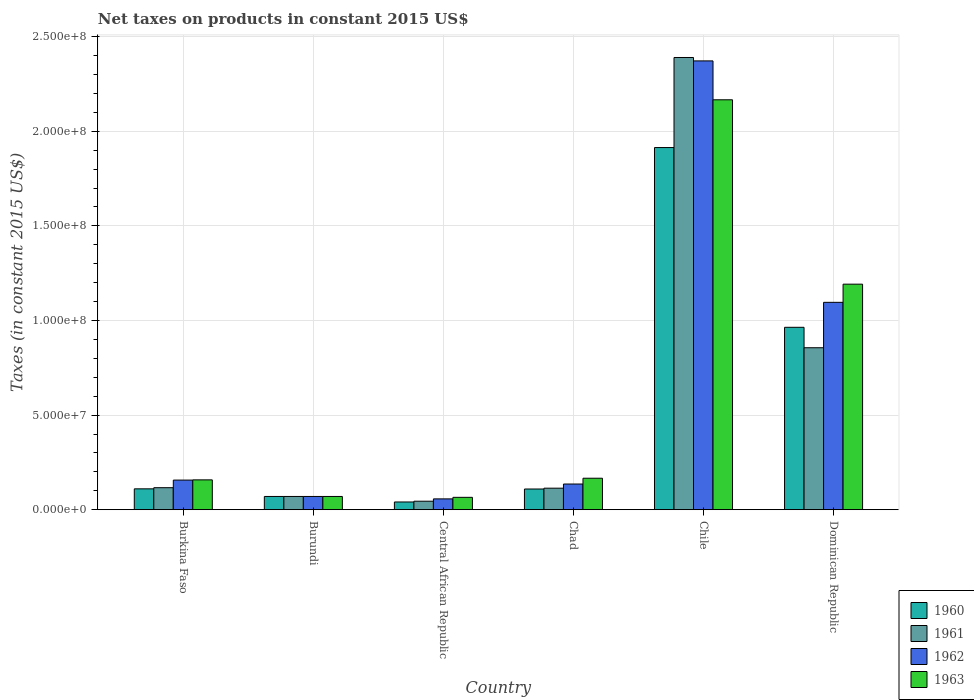Are the number of bars on each tick of the X-axis equal?
Give a very brief answer. Yes. What is the label of the 6th group of bars from the left?
Keep it short and to the point. Dominican Republic. What is the net taxes on products in 1961 in Dominican Republic?
Keep it short and to the point. 8.56e+07. Across all countries, what is the maximum net taxes on products in 1962?
Your response must be concise. 2.37e+08. Across all countries, what is the minimum net taxes on products in 1962?
Ensure brevity in your answer.  5.71e+06. In which country was the net taxes on products in 1963 minimum?
Provide a succinct answer. Central African Republic. What is the total net taxes on products in 1963 in the graph?
Your answer should be compact. 3.82e+08. What is the difference between the net taxes on products in 1963 in Burundi and that in Chad?
Keep it short and to the point. -9.63e+06. What is the difference between the net taxes on products in 1960 in Dominican Republic and the net taxes on products in 1961 in Central African Republic?
Your answer should be compact. 9.19e+07. What is the average net taxes on products in 1962 per country?
Give a very brief answer. 6.48e+07. What is the difference between the net taxes on products of/in 1961 and net taxes on products of/in 1963 in Chad?
Your answer should be very brief. -5.26e+06. In how many countries, is the net taxes on products in 1963 greater than 150000000 US$?
Give a very brief answer. 1. What is the ratio of the net taxes on products in 1961 in Chad to that in Dominican Republic?
Your answer should be very brief. 0.13. Is the net taxes on products in 1963 in Burundi less than that in Dominican Republic?
Make the answer very short. Yes. What is the difference between the highest and the second highest net taxes on products in 1962?
Your response must be concise. 9.40e+07. What is the difference between the highest and the lowest net taxes on products in 1963?
Your answer should be compact. 2.10e+08. Is it the case that in every country, the sum of the net taxes on products in 1961 and net taxes on products in 1960 is greater than the sum of net taxes on products in 1962 and net taxes on products in 1963?
Ensure brevity in your answer.  No. What does the 3rd bar from the right in Burundi represents?
Offer a very short reply. 1961. Are all the bars in the graph horizontal?
Offer a very short reply. No. What is the difference between two consecutive major ticks on the Y-axis?
Make the answer very short. 5.00e+07. Does the graph contain any zero values?
Make the answer very short. No. Does the graph contain grids?
Offer a terse response. Yes. Where does the legend appear in the graph?
Offer a very short reply. Bottom right. How many legend labels are there?
Offer a very short reply. 4. What is the title of the graph?
Your response must be concise. Net taxes on products in constant 2015 US$. Does "2006" appear as one of the legend labels in the graph?
Your answer should be very brief. No. What is the label or title of the Y-axis?
Keep it short and to the point. Taxes (in constant 2015 US$). What is the Taxes (in constant 2015 US$) of 1960 in Burkina Faso?
Provide a short and direct response. 1.10e+07. What is the Taxes (in constant 2015 US$) of 1961 in Burkina Faso?
Give a very brief answer. 1.16e+07. What is the Taxes (in constant 2015 US$) in 1962 in Burkina Faso?
Your answer should be compact. 1.56e+07. What is the Taxes (in constant 2015 US$) in 1963 in Burkina Faso?
Ensure brevity in your answer.  1.58e+07. What is the Taxes (in constant 2015 US$) of 1960 in Central African Republic?
Provide a short and direct response. 4.08e+06. What is the Taxes (in constant 2015 US$) in 1961 in Central African Republic?
Give a very brief answer. 4.49e+06. What is the Taxes (in constant 2015 US$) of 1962 in Central African Republic?
Keep it short and to the point. 5.71e+06. What is the Taxes (in constant 2015 US$) in 1963 in Central African Republic?
Provide a short and direct response. 6.53e+06. What is the Taxes (in constant 2015 US$) of 1960 in Chad?
Make the answer very short. 1.09e+07. What is the Taxes (in constant 2015 US$) of 1961 in Chad?
Provide a succinct answer. 1.14e+07. What is the Taxes (in constant 2015 US$) in 1962 in Chad?
Make the answer very short. 1.36e+07. What is the Taxes (in constant 2015 US$) of 1963 in Chad?
Your response must be concise. 1.66e+07. What is the Taxes (in constant 2015 US$) in 1960 in Chile?
Keep it short and to the point. 1.91e+08. What is the Taxes (in constant 2015 US$) in 1961 in Chile?
Ensure brevity in your answer.  2.39e+08. What is the Taxes (in constant 2015 US$) of 1962 in Chile?
Keep it short and to the point. 2.37e+08. What is the Taxes (in constant 2015 US$) of 1963 in Chile?
Provide a short and direct response. 2.17e+08. What is the Taxes (in constant 2015 US$) of 1960 in Dominican Republic?
Give a very brief answer. 9.64e+07. What is the Taxes (in constant 2015 US$) of 1961 in Dominican Republic?
Offer a very short reply. 8.56e+07. What is the Taxes (in constant 2015 US$) of 1962 in Dominican Republic?
Provide a short and direct response. 1.10e+08. What is the Taxes (in constant 2015 US$) of 1963 in Dominican Republic?
Keep it short and to the point. 1.19e+08. Across all countries, what is the maximum Taxes (in constant 2015 US$) in 1960?
Keep it short and to the point. 1.91e+08. Across all countries, what is the maximum Taxes (in constant 2015 US$) in 1961?
Your answer should be very brief. 2.39e+08. Across all countries, what is the maximum Taxes (in constant 2015 US$) of 1962?
Offer a very short reply. 2.37e+08. Across all countries, what is the maximum Taxes (in constant 2015 US$) in 1963?
Provide a short and direct response. 2.17e+08. Across all countries, what is the minimum Taxes (in constant 2015 US$) in 1960?
Offer a very short reply. 4.08e+06. Across all countries, what is the minimum Taxes (in constant 2015 US$) in 1961?
Make the answer very short. 4.49e+06. Across all countries, what is the minimum Taxes (in constant 2015 US$) of 1962?
Make the answer very short. 5.71e+06. Across all countries, what is the minimum Taxes (in constant 2015 US$) of 1963?
Give a very brief answer. 6.53e+06. What is the total Taxes (in constant 2015 US$) of 1960 in the graph?
Make the answer very short. 3.21e+08. What is the total Taxes (in constant 2015 US$) in 1961 in the graph?
Provide a succinct answer. 3.59e+08. What is the total Taxes (in constant 2015 US$) of 1962 in the graph?
Your answer should be very brief. 3.89e+08. What is the total Taxes (in constant 2015 US$) in 1963 in the graph?
Your answer should be very brief. 3.82e+08. What is the difference between the Taxes (in constant 2015 US$) in 1960 in Burkina Faso and that in Burundi?
Provide a succinct answer. 4.02e+06. What is the difference between the Taxes (in constant 2015 US$) in 1961 in Burkina Faso and that in Burundi?
Give a very brief answer. 4.63e+06. What is the difference between the Taxes (in constant 2015 US$) in 1962 in Burkina Faso and that in Burundi?
Your answer should be very brief. 8.65e+06. What is the difference between the Taxes (in constant 2015 US$) of 1963 in Burkina Faso and that in Burundi?
Your answer should be very brief. 8.77e+06. What is the difference between the Taxes (in constant 2015 US$) of 1960 in Burkina Faso and that in Central African Republic?
Your answer should be compact. 6.94e+06. What is the difference between the Taxes (in constant 2015 US$) of 1961 in Burkina Faso and that in Central African Republic?
Your response must be concise. 7.15e+06. What is the difference between the Taxes (in constant 2015 US$) in 1962 in Burkina Faso and that in Central African Republic?
Offer a very short reply. 9.93e+06. What is the difference between the Taxes (in constant 2015 US$) of 1963 in Burkina Faso and that in Central African Republic?
Offer a very short reply. 9.24e+06. What is the difference between the Taxes (in constant 2015 US$) of 1960 in Burkina Faso and that in Chad?
Make the answer very short. 8.71e+04. What is the difference between the Taxes (in constant 2015 US$) in 1961 in Burkina Faso and that in Chad?
Keep it short and to the point. 2.61e+05. What is the difference between the Taxes (in constant 2015 US$) of 1962 in Burkina Faso and that in Chad?
Keep it short and to the point. 2.08e+06. What is the difference between the Taxes (in constant 2015 US$) of 1963 in Burkina Faso and that in Chad?
Give a very brief answer. -8.65e+05. What is the difference between the Taxes (in constant 2015 US$) of 1960 in Burkina Faso and that in Chile?
Offer a terse response. -1.80e+08. What is the difference between the Taxes (in constant 2015 US$) in 1961 in Burkina Faso and that in Chile?
Provide a succinct answer. -2.27e+08. What is the difference between the Taxes (in constant 2015 US$) of 1962 in Burkina Faso and that in Chile?
Offer a very short reply. -2.22e+08. What is the difference between the Taxes (in constant 2015 US$) in 1963 in Burkina Faso and that in Chile?
Your response must be concise. -2.01e+08. What is the difference between the Taxes (in constant 2015 US$) of 1960 in Burkina Faso and that in Dominican Republic?
Provide a short and direct response. -8.54e+07. What is the difference between the Taxes (in constant 2015 US$) in 1961 in Burkina Faso and that in Dominican Republic?
Provide a short and direct response. -7.40e+07. What is the difference between the Taxes (in constant 2015 US$) of 1962 in Burkina Faso and that in Dominican Republic?
Provide a succinct answer. -9.40e+07. What is the difference between the Taxes (in constant 2015 US$) in 1963 in Burkina Faso and that in Dominican Republic?
Make the answer very short. -1.03e+08. What is the difference between the Taxes (in constant 2015 US$) in 1960 in Burundi and that in Central African Republic?
Your response must be concise. 2.92e+06. What is the difference between the Taxes (in constant 2015 US$) of 1961 in Burundi and that in Central African Republic?
Provide a succinct answer. 2.51e+06. What is the difference between the Taxes (in constant 2015 US$) in 1962 in Burundi and that in Central African Republic?
Give a very brief answer. 1.29e+06. What is the difference between the Taxes (in constant 2015 US$) in 1963 in Burundi and that in Central African Republic?
Provide a succinct answer. 4.70e+05. What is the difference between the Taxes (in constant 2015 US$) of 1960 in Burundi and that in Chad?
Provide a short and direct response. -3.94e+06. What is the difference between the Taxes (in constant 2015 US$) in 1961 in Burundi and that in Chad?
Provide a short and direct response. -4.37e+06. What is the difference between the Taxes (in constant 2015 US$) of 1962 in Burundi and that in Chad?
Give a very brief answer. -6.57e+06. What is the difference between the Taxes (in constant 2015 US$) in 1963 in Burundi and that in Chad?
Provide a succinct answer. -9.63e+06. What is the difference between the Taxes (in constant 2015 US$) of 1960 in Burundi and that in Chile?
Your answer should be compact. -1.84e+08. What is the difference between the Taxes (in constant 2015 US$) of 1961 in Burundi and that in Chile?
Keep it short and to the point. -2.32e+08. What is the difference between the Taxes (in constant 2015 US$) of 1962 in Burundi and that in Chile?
Provide a short and direct response. -2.30e+08. What is the difference between the Taxes (in constant 2015 US$) in 1963 in Burundi and that in Chile?
Make the answer very short. -2.10e+08. What is the difference between the Taxes (in constant 2015 US$) of 1960 in Burundi and that in Dominican Republic?
Your response must be concise. -8.94e+07. What is the difference between the Taxes (in constant 2015 US$) in 1961 in Burundi and that in Dominican Republic?
Offer a terse response. -7.86e+07. What is the difference between the Taxes (in constant 2015 US$) in 1962 in Burundi and that in Dominican Republic?
Make the answer very short. -1.03e+08. What is the difference between the Taxes (in constant 2015 US$) of 1963 in Burundi and that in Dominican Republic?
Keep it short and to the point. -1.12e+08. What is the difference between the Taxes (in constant 2015 US$) of 1960 in Central African Republic and that in Chad?
Your response must be concise. -6.86e+06. What is the difference between the Taxes (in constant 2015 US$) of 1961 in Central African Republic and that in Chad?
Your answer should be very brief. -6.88e+06. What is the difference between the Taxes (in constant 2015 US$) of 1962 in Central African Republic and that in Chad?
Make the answer very short. -7.86e+06. What is the difference between the Taxes (in constant 2015 US$) in 1963 in Central African Republic and that in Chad?
Provide a succinct answer. -1.01e+07. What is the difference between the Taxes (in constant 2015 US$) in 1960 in Central African Republic and that in Chile?
Offer a terse response. -1.87e+08. What is the difference between the Taxes (in constant 2015 US$) in 1961 in Central African Republic and that in Chile?
Your answer should be compact. -2.35e+08. What is the difference between the Taxes (in constant 2015 US$) in 1962 in Central African Republic and that in Chile?
Ensure brevity in your answer.  -2.31e+08. What is the difference between the Taxes (in constant 2015 US$) of 1963 in Central African Republic and that in Chile?
Your answer should be compact. -2.10e+08. What is the difference between the Taxes (in constant 2015 US$) in 1960 in Central African Republic and that in Dominican Republic?
Your answer should be very brief. -9.23e+07. What is the difference between the Taxes (in constant 2015 US$) in 1961 in Central African Republic and that in Dominican Republic?
Your response must be concise. -8.11e+07. What is the difference between the Taxes (in constant 2015 US$) of 1962 in Central African Republic and that in Dominican Republic?
Provide a short and direct response. -1.04e+08. What is the difference between the Taxes (in constant 2015 US$) of 1963 in Central African Republic and that in Dominican Republic?
Give a very brief answer. -1.13e+08. What is the difference between the Taxes (in constant 2015 US$) of 1960 in Chad and that in Chile?
Provide a short and direct response. -1.80e+08. What is the difference between the Taxes (in constant 2015 US$) of 1961 in Chad and that in Chile?
Make the answer very short. -2.28e+08. What is the difference between the Taxes (in constant 2015 US$) of 1962 in Chad and that in Chile?
Ensure brevity in your answer.  -2.24e+08. What is the difference between the Taxes (in constant 2015 US$) of 1963 in Chad and that in Chile?
Make the answer very short. -2.00e+08. What is the difference between the Taxes (in constant 2015 US$) of 1960 in Chad and that in Dominican Republic?
Provide a short and direct response. -8.55e+07. What is the difference between the Taxes (in constant 2015 US$) of 1961 in Chad and that in Dominican Republic?
Your response must be concise. -7.42e+07. What is the difference between the Taxes (in constant 2015 US$) in 1962 in Chad and that in Dominican Republic?
Keep it short and to the point. -9.60e+07. What is the difference between the Taxes (in constant 2015 US$) in 1963 in Chad and that in Dominican Republic?
Your answer should be compact. -1.03e+08. What is the difference between the Taxes (in constant 2015 US$) in 1960 in Chile and that in Dominican Republic?
Your answer should be very brief. 9.50e+07. What is the difference between the Taxes (in constant 2015 US$) of 1961 in Chile and that in Dominican Republic?
Provide a short and direct response. 1.53e+08. What is the difference between the Taxes (in constant 2015 US$) of 1962 in Chile and that in Dominican Republic?
Provide a short and direct response. 1.28e+08. What is the difference between the Taxes (in constant 2015 US$) of 1963 in Chile and that in Dominican Republic?
Keep it short and to the point. 9.74e+07. What is the difference between the Taxes (in constant 2015 US$) of 1960 in Burkina Faso and the Taxes (in constant 2015 US$) of 1961 in Burundi?
Ensure brevity in your answer.  4.02e+06. What is the difference between the Taxes (in constant 2015 US$) in 1960 in Burkina Faso and the Taxes (in constant 2015 US$) in 1962 in Burundi?
Make the answer very short. 4.02e+06. What is the difference between the Taxes (in constant 2015 US$) of 1960 in Burkina Faso and the Taxes (in constant 2015 US$) of 1963 in Burundi?
Your response must be concise. 4.02e+06. What is the difference between the Taxes (in constant 2015 US$) in 1961 in Burkina Faso and the Taxes (in constant 2015 US$) in 1962 in Burundi?
Make the answer very short. 4.63e+06. What is the difference between the Taxes (in constant 2015 US$) in 1961 in Burkina Faso and the Taxes (in constant 2015 US$) in 1963 in Burundi?
Provide a short and direct response. 4.63e+06. What is the difference between the Taxes (in constant 2015 US$) in 1962 in Burkina Faso and the Taxes (in constant 2015 US$) in 1963 in Burundi?
Offer a terse response. 8.65e+06. What is the difference between the Taxes (in constant 2015 US$) of 1960 in Burkina Faso and the Taxes (in constant 2015 US$) of 1961 in Central African Republic?
Provide a succinct answer. 6.54e+06. What is the difference between the Taxes (in constant 2015 US$) of 1960 in Burkina Faso and the Taxes (in constant 2015 US$) of 1962 in Central African Republic?
Provide a succinct answer. 5.31e+06. What is the difference between the Taxes (in constant 2015 US$) in 1960 in Burkina Faso and the Taxes (in constant 2015 US$) in 1963 in Central African Republic?
Provide a short and direct response. 4.49e+06. What is the difference between the Taxes (in constant 2015 US$) of 1961 in Burkina Faso and the Taxes (in constant 2015 US$) of 1962 in Central African Republic?
Your answer should be compact. 5.92e+06. What is the difference between the Taxes (in constant 2015 US$) of 1961 in Burkina Faso and the Taxes (in constant 2015 US$) of 1963 in Central African Republic?
Ensure brevity in your answer.  5.10e+06. What is the difference between the Taxes (in constant 2015 US$) in 1962 in Burkina Faso and the Taxes (in constant 2015 US$) in 1963 in Central African Republic?
Provide a short and direct response. 9.12e+06. What is the difference between the Taxes (in constant 2015 US$) in 1960 in Burkina Faso and the Taxes (in constant 2015 US$) in 1961 in Chad?
Your answer should be compact. -3.47e+05. What is the difference between the Taxes (in constant 2015 US$) in 1960 in Burkina Faso and the Taxes (in constant 2015 US$) in 1962 in Chad?
Offer a very short reply. -2.55e+06. What is the difference between the Taxes (in constant 2015 US$) in 1960 in Burkina Faso and the Taxes (in constant 2015 US$) in 1963 in Chad?
Keep it short and to the point. -5.61e+06. What is the difference between the Taxes (in constant 2015 US$) in 1961 in Burkina Faso and the Taxes (in constant 2015 US$) in 1962 in Chad?
Ensure brevity in your answer.  -1.94e+06. What is the difference between the Taxes (in constant 2015 US$) of 1961 in Burkina Faso and the Taxes (in constant 2015 US$) of 1963 in Chad?
Ensure brevity in your answer.  -5.00e+06. What is the difference between the Taxes (in constant 2015 US$) in 1962 in Burkina Faso and the Taxes (in constant 2015 US$) in 1963 in Chad?
Provide a short and direct response. -9.87e+05. What is the difference between the Taxes (in constant 2015 US$) of 1960 in Burkina Faso and the Taxes (in constant 2015 US$) of 1961 in Chile?
Offer a very short reply. -2.28e+08. What is the difference between the Taxes (in constant 2015 US$) of 1960 in Burkina Faso and the Taxes (in constant 2015 US$) of 1962 in Chile?
Provide a succinct answer. -2.26e+08. What is the difference between the Taxes (in constant 2015 US$) in 1960 in Burkina Faso and the Taxes (in constant 2015 US$) in 1963 in Chile?
Provide a succinct answer. -2.06e+08. What is the difference between the Taxes (in constant 2015 US$) in 1961 in Burkina Faso and the Taxes (in constant 2015 US$) in 1962 in Chile?
Your answer should be very brief. -2.26e+08. What is the difference between the Taxes (in constant 2015 US$) in 1961 in Burkina Faso and the Taxes (in constant 2015 US$) in 1963 in Chile?
Your answer should be very brief. -2.05e+08. What is the difference between the Taxes (in constant 2015 US$) of 1962 in Burkina Faso and the Taxes (in constant 2015 US$) of 1963 in Chile?
Your response must be concise. -2.01e+08. What is the difference between the Taxes (in constant 2015 US$) in 1960 in Burkina Faso and the Taxes (in constant 2015 US$) in 1961 in Dominican Republic?
Make the answer very short. -7.46e+07. What is the difference between the Taxes (in constant 2015 US$) in 1960 in Burkina Faso and the Taxes (in constant 2015 US$) in 1962 in Dominican Republic?
Provide a short and direct response. -9.86e+07. What is the difference between the Taxes (in constant 2015 US$) of 1960 in Burkina Faso and the Taxes (in constant 2015 US$) of 1963 in Dominican Republic?
Ensure brevity in your answer.  -1.08e+08. What is the difference between the Taxes (in constant 2015 US$) in 1961 in Burkina Faso and the Taxes (in constant 2015 US$) in 1962 in Dominican Republic?
Offer a terse response. -9.80e+07. What is the difference between the Taxes (in constant 2015 US$) in 1961 in Burkina Faso and the Taxes (in constant 2015 US$) in 1963 in Dominican Republic?
Ensure brevity in your answer.  -1.08e+08. What is the difference between the Taxes (in constant 2015 US$) in 1962 in Burkina Faso and the Taxes (in constant 2015 US$) in 1963 in Dominican Republic?
Your answer should be compact. -1.04e+08. What is the difference between the Taxes (in constant 2015 US$) in 1960 in Burundi and the Taxes (in constant 2015 US$) in 1961 in Central African Republic?
Keep it short and to the point. 2.51e+06. What is the difference between the Taxes (in constant 2015 US$) in 1960 in Burundi and the Taxes (in constant 2015 US$) in 1962 in Central African Republic?
Give a very brief answer. 1.29e+06. What is the difference between the Taxes (in constant 2015 US$) of 1960 in Burundi and the Taxes (in constant 2015 US$) of 1963 in Central African Republic?
Your answer should be compact. 4.70e+05. What is the difference between the Taxes (in constant 2015 US$) in 1961 in Burundi and the Taxes (in constant 2015 US$) in 1962 in Central African Republic?
Provide a succinct answer. 1.29e+06. What is the difference between the Taxes (in constant 2015 US$) in 1961 in Burundi and the Taxes (in constant 2015 US$) in 1963 in Central African Republic?
Keep it short and to the point. 4.70e+05. What is the difference between the Taxes (in constant 2015 US$) in 1962 in Burundi and the Taxes (in constant 2015 US$) in 1963 in Central African Republic?
Your answer should be compact. 4.70e+05. What is the difference between the Taxes (in constant 2015 US$) in 1960 in Burundi and the Taxes (in constant 2015 US$) in 1961 in Chad?
Your response must be concise. -4.37e+06. What is the difference between the Taxes (in constant 2015 US$) in 1960 in Burundi and the Taxes (in constant 2015 US$) in 1962 in Chad?
Offer a very short reply. -6.57e+06. What is the difference between the Taxes (in constant 2015 US$) in 1960 in Burundi and the Taxes (in constant 2015 US$) in 1963 in Chad?
Your response must be concise. -9.63e+06. What is the difference between the Taxes (in constant 2015 US$) in 1961 in Burundi and the Taxes (in constant 2015 US$) in 1962 in Chad?
Give a very brief answer. -6.57e+06. What is the difference between the Taxes (in constant 2015 US$) in 1961 in Burundi and the Taxes (in constant 2015 US$) in 1963 in Chad?
Provide a succinct answer. -9.63e+06. What is the difference between the Taxes (in constant 2015 US$) of 1962 in Burundi and the Taxes (in constant 2015 US$) of 1963 in Chad?
Provide a short and direct response. -9.63e+06. What is the difference between the Taxes (in constant 2015 US$) of 1960 in Burundi and the Taxes (in constant 2015 US$) of 1961 in Chile?
Ensure brevity in your answer.  -2.32e+08. What is the difference between the Taxes (in constant 2015 US$) of 1960 in Burundi and the Taxes (in constant 2015 US$) of 1962 in Chile?
Offer a very short reply. -2.30e+08. What is the difference between the Taxes (in constant 2015 US$) of 1960 in Burundi and the Taxes (in constant 2015 US$) of 1963 in Chile?
Your response must be concise. -2.10e+08. What is the difference between the Taxes (in constant 2015 US$) of 1961 in Burundi and the Taxes (in constant 2015 US$) of 1962 in Chile?
Your answer should be compact. -2.30e+08. What is the difference between the Taxes (in constant 2015 US$) in 1961 in Burundi and the Taxes (in constant 2015 US$) in 1963 in Chile?
Provide a short and direct response. -2.10e+08. What is the difference between the Taxes (in constant 2015 US$) of 1962 in Burundi and the Taxes (in constant 2015 US$) of 1963 in Chile?
Your response must be concise. -2.10e+08. What is the difference between the Taxes (in constant 2015 US$) in 1960 in Burundi and the Taxes (in constant 2015 US$) in 1961 in Dominican Republic?
Your answer should be very brief. -7.86e+07. What is the difference between the Taxes (in constant 2015 US$) of 1960 in Burundi and the Taxes (in constant 2015 US$) of 1962 in Dominican Republic?
Your answer should be very brief. -1.03e+08. What is the difference between the Taxes (in constant 2015 US$) of 1960 in Burundi and the Taxes (in constant 2015 US$) of 1963 in Dominican Republic?
Offer a terse response. -1.12e+08. What is the difference between the Taxes (in constant 2015 US$) in 1961 in Burundi and the Taxes (in constant 2015 US$) in 1962 in Dominican Republic?
Provide a short and direct response. -1.03e+08. What is the difference between the Taxes (in constant 2015 US$) in 1961 in Burundi and the Taxes (in constant 2015 US$) in 1963 in Dominican Republic?
Keep it short and to the point. -1.12e+08. What is the difference between the Taxes (in constant 2015 US$) in 1962 in Burundi and the Taxes (in constant 2015 US$) in 1963 in Dominican Republic?
Ensure brevity in your answer.  -1.12e+08. What is the difference between the Taxes (in constant 2015 US$) of 1960 in Central African Republic and the Taxes (in constant 2015 US$) of 1961 in Chad?
Give a very brief answer. -7.29e+06. What is the difference between the Taxes (in constant 2015 US$) of 1960 in Central African Republic and the Taxes (in constant 2015 US$) of 1962 in Chad?
Provide a short and direct response. -9.49e+06. What is the difference between the Taxes (in constant 2015 US$) in 1960 in Central African Republic and the Taxes (in constant 2015 US$) in 1963 in Chad?
Your answer should be very brief. -1.26e+07. What is the difference between the Taxes (in constant 2015 US$) of 1961 in Central African Republic and the Taxes (in constant 2015 US$) of 1962 in Chad?
Offer a very short reply. -9.08e+06. What is the difference between the Taxes (in constant 2015 US$) of 1961 in Central African Republic and the Taxes (in constant 2015 US$) of 1963 in Chad?
Your answer should be compact. -1.21e+07. What is the difference between the Taxes (in constant 2015 US$) of 1962 in Central African Republic and the Taxes (in constant 2015 US$) of 1963 in Chad?
Offer a terse response. -1.09e+07. What is the difference between the Taxes (in constant 2015 US$) of 1960 in Central African Republic and the Taxes (in constant 2015 US$) of 1961 in Chile?
Your answer should be compact. -2.35e+08. What is the difference between the Taxes (in constant 2015 US$) of 1960 in Central African Republic and the Taxes (in constant 2015 US$) of 1962 in Chile?
Offer a very short reply. -2.33e+08. What is the difference between the Taxes (in constant 2015 US$) of 1960 in Central African Republic and the Taxes (in constant 2015 US$) of 1963 in Chile?
Keep it short and to the point. -2.13e+08. What is the difference between the Taxes (in constant 2015 US$) in 1961 in Central African Republic and the Taxes (in constant 2015 US$) in 1962 in Chile?
Your answer should be very brief. -2.33e+08. What is the difference between the Taxes (in constant 2015 US$) of 1961 in Central African Republic and the Taxes (in constant 2015 US$) of 1963 in Chile?
Provide a short and direct response. -2.12e+08. What is the difference between the Taxes (in constant 2015 US$) in 1962 in Central African Republic and the Taxes (in constant 2015 US$) in 1963 in Chile?
Provide a succinct answer. -2.11e+08. What is the difference between the Taxes (in constant 2015 US$) of 1960 in Central African Republic and the Taxes (in constant 2015 US$) of 1961 in Dominican Republic?
Your answer should be very brief. -8.15e+07. What is the difference between the Taxes (in constant 2015 US$) of 1960 in Central African Republic and the Taxes (in constant 2015 US$) of 1962 in Dominican Republic?
Your answer should be compact. -1.06e+08. What is the difference between the Taxes (in constant 2015 US$) in 1960 in Central African Republic and the Taxes (in constant 2015 US$) in 1963 in Dominican Republic?
Offer a very short reply. -1.15e+08. What is the difference between the Taxes (in constant 2015 US$) in 1961 in Central African Republic and the Taxes (in constant 2015 US$) in 1962 in Dominican Republic?
Keep it short and to the point. -1.05e+08. What is the difference between the Taxes (in constant 2015 US$) in 1961 in Central African Republic and the Taxes (in constant 2015 US$) in 1963 in Dominican Republic?
Your response must be concise. -1.15e+08. What is the difference between the Taxes (in constant 2015 US$) of 1962 in Central African Republic and the Taxes (in constant 2015 US$) of 1963 in Dominican Republic?
Your answer should be compact. -1.13e+08. What is the difference between the Taxes (in constant 2015 US$) of 1960 in Chad and the Taxes (in constant 2015 US$) of 1961 in Chile?
Provide a succinct answer. -2.28e+08. What is the difference between the Taxes (in constant 2015 US$) of 1960 in Chad and the Taxes (in constant 2015 US$) of 1962 in Chile?
Your answer should be compact. -2.26e+08. What is the difference between the Taxes (in constant 2015 US$) of 1960 in Chad and the Taxes (in constant 2015 US$) of 1963 in Chile?
Provide a succinct answer. -2.06e+08. What is the difference between the Taxes (in constant 2015 US$) of 1961 in Chad and the Taxes (in constant 2015 US$) of 1962 in Chile?
Ensure brevity in your answer.  -2.26e+08. What is the difference between the Taxes (in constant 2015 US$) of 1961 in Chad and the Taxes (in constant 2015 US$) of 1963 in Chile?
Your answer should be very brief. -2.05e+08. What is the difference between the Taxes (in constant 2015 US$) in 1962 in Chad and the Taxes (in constant 2015 US$) in 1963 in Chile?
Your answer should be compact. -2.03e+08. What is the difference between the Taxes (in constant 2015 US$) in 1960 in Chad and the Taxes (in constant 2015 US$) in 1961 in Dominican Republic?
Your response must be concise. -7.47e+07. What is the difference between the Taxes (in constant 2015 US$) of 1960 in Chad and the Taxes (in constant 2015 US$) of 1962 in Dominican Republic?
Ensure brevity in your answer.  -9.87e+07. What is the difference between the Taxes (in constant 2015 US$) in 1960 in Chad and the Taxes (in constant 2015 US$) in 1963 in Dominican Republic?
Offer a terse response. -1.08e+08. What is the difference between the Taxes (in constant 2015 US$) of 1961 in Chad and the Taxes (in constant 2015 US$) of 1962 in Dominican Republic?
Your answer should be very brief. -9.82e+07. What is the difference between the Taxes (in constant 2015 US$) of 1961 in Chad and the Taxes (in constant 2015 US$) of 1963 in Dominican Republic?
Keep it short and to the point. -1.08e+08. What is the difference between the Taxes (in constant 2015 US$) of 1962 in Chad and the Taxes (in constant 2015 US$) of 1963 in Dominican Republic?
Provide a succinct answer. -1.06e+08. What is the difference between the Taxes (in constant 2015 US$) in 1960 in Chile and the Taxes (in constant 2015 US$) in 1961 in Dominican Republic?
Offer a very short reply. 1.06e+08. What is the difference between the Taxes (in constant 2015 US$) of 1960 in Chile and the Taxes (in constant 2015 US$) of 1962 in Dominican Republic?
Your answer should be very brief. 8.18e+07. What is the difference between the Taxes (in constant 2015 US$) of 1960 in Chile and the Taxes (in constant 2015 US$) of 1963 in Dominican Republic?
Your response must be concise. 7.22e+07. What is the difference between the Taxes (in constant 2015 US$) of 1961 in Chile and the Taxes (in constant 2015 US$) of 1962 in Dominican Republic?
Your answer should be very brief. 1.29e+08. What is the difference between the Taxes (in constant 2015 US$) in 1961 in Chile and the Taxes (in constant 2015 US$) in 1963 in Dominican Republic?
Provide a succinct answer. 1.20e+08. What is the difference between the Taxes (in constant 2015 US$) in 1962 in Chile and the Taxes (in constant 2015 US$) in 1963 in Dominican Republic?
Provide a succinct answer. 1.18e+08. What is the average Taxes (in constant 2015 US$) in 1960 per country?
Give a very brief answer. 5.35e+07. What is the average Taxes (in constant 2015 US$) in 1961 per country?
Offer a very short reply. 5.98e+07. What is the average Taxes (in constant 2015 US$) of 1962 per country?
Provide a succinct answer. 6.48e+07. What is the average Taxes (in constant 2015 US$) in 1963 per country?
Offer a terse response. 6.36e+07. What is the difference between the Taxes (in constant 2015 US$) of 1960 and Taxes (in constant 2015 US$) of 1961 in Burkina Faso?
Keep it short and to the point. -6.08e+05. What is the difference between the Taxes (in constant 2015 US$) of 1960 and Taxes (in constant 2015 US$) of 1962 in Burkina Faso?
Provide a succinct answer. -4.62e+06. What is the difference between the Taxes (in constant 2015 US$) of 1960 and Taxes (in constant 2015 US$) of 1963 in Burkina Faso?
Offer a terse response. -4.75e+06. What is the difference between the Taxes (in constant 2015 US$) of 1961 and Taxes (in constant 2015 US$) of 1962 in Burkina Faso?
Your answer should be compact. -4.02e+06. What is the difference between the Taxes (in constant 2015 US$) in 1961 and Taxes (in constant 2015 US$) in 1963 in Burkina Faso?
Your answer should be compact. -4.14e+06. What is the difference between the Taxes (in constant 2015 US$) in 1962 and Taxes (in constant 2015 US$) in 1963 in Burkina Faso?
Offer a terse response. -1.22e+05. What is the difference between the Taxes (in constant 2015 US$) in 1960 and Taxes (in constant 2015 US$) in 1961 in Burundi?
Offer a very short reply. 0. What is the difference between the Taxes (in constant 2015 US$) of 1960 and Taxes (in constant 2015 US$) of 1963 in Burundi?
Your answer should be compact. 0. What is the difference between the Taxes (in constant 2015 US$) of 1961 and Taxes (in constant 2015 US$) of 1963 in Burundi?
Provide a succinct answer. 0. What is the difference between the Taxes (in constant 2015 US$) of 1960 and Taxes (in constant 2015 US$) of 1961 in Central African Republic?
Give a very brief answer. -4.07e+05. What is the difference between the Taxes (in constant 2015 US$) of 1960 and Taxes (in constant 2015 US$) of 1962 in Central African Republic?
Your answer should be very brief. -1.64e+06. What is the difference between the Taxes (in constant 2015 US$) of 1960 and Taxes (in constant 2015 US$) of 1963 in Central African Republic?
Offer a terse response. -2.45e+06. What is the difference between the Taxes (in constant 2015 US$) of 1961 and Taxes (in constant 2015 US$) of 1962 in Central African Republic?
Give a very brief answer. -1.23e+06. What is the difference between the Taxes (in constant 2015 US$) in 1961 and Taxes (in constant 2015 US$) in 1963 in Central African Republic?
Ensure brevity in your answer.  -2.05e+06. What is the difference between the Taxes (in constant 2015 US$) in 1962 and Taxes (in constant 2015 US$) in 1963 in Central African Republic?
Give a very brief answer. -8.16e+05. What is the difference between the Taxes (in constant 2015 US$) of 1960 and Taxes (in constant 2015 US$) of 1961 in Chad?
Give a very brief answer. -4.34e+05. What is the difference between the Taxes (in constant 2015 US$) of 1960 and Taxes (in constant 2015 US$) of 1962 in Chad?
Provide a succinct answer. -2.63e+06. What is the difference between the Taxes (in constant 2015 US$) in 1960 and Taxes (in constant 2015 US$) in 1963 in Chad?
Your response must be concise. -5.70e+06. What is the difference between the Taxes (in constant 2015 US$) of 1961 and Taxes (in constant 2015 US$) of 1962 in Chad?
Provide a succinct answer. -2.20e+06. What is the difference between the Taxes (in constant 2015 US$) of 1961 and Taxes (in constant 2015 US$) of 1963 in Chad?
Your answer should be very brief. -5.26e+06. What is the difference between the Taxes (in constant 2015 US$) of 1962 and Taxes (in constant 2015 US$) of 1963 in Chad?
Ensure brevity in your answer.  -3.06e+06. What is the difference between the Taxes (in constant 2015 US$) of 1960 and Taxes (in constant 2015 US$) of 1961 in Chile?
Your response must be concise. -4.76e+07. What is the difference between the Taxes (in constant 2015 US$) in 1960 and Taxes (in constant 2015 US$) in 1962 in Chile?
Offer a terse response. -4.58e+07. What is the difference between the Taxes (in constant 2015 US$) of 1960 and Taxes (in constant 2015 US$) of 1963 in Chile?
Ensure brevity in your answer.  -2.52e+07. What is the difference between the Taxes (in constant 2015 US$) in 1961 and Taxes (in constant 2015 US$) in 1962 in Chile?
Provide a short and direct response. 1.81e+06. What is the difference between the Taxes (in constant 2015 US$) of 1961 and Taxes (in constant 2015 US$) of 1963 in Chile?
Offer a terse response. 2.24e+07. What is the difference between the Taxes (in constant 2015 US$) in 1962 and Taxes (in constant 2015 US$) in 1963 in Chile?
Make the answer very short. 2.06e+07. What is the difference between the Taxes (in constant 2015 US$) in 1960 and Taxes (in constant 2015 US$) in 1961 in Dominican Republic?
Your answer should be compact. 1.08e+07. What is the difference between the Taxes (in constant 2015 US$) in 1960 and Taxes (in constant 2015 US$) in 1962 in Dominican Republic?
Your answer should be compact. -1.32e+07. What is the difference between the Taxes (in constant 2015 US$) of 1960 and Taxes (in constant 2015 US$) of 1963 in Dominican Republic?
Offer a very short reply. -2.28e+07. What is the difference between the Taxes (in constant 2015 US$) in 1961 and Taxes (in constant 2015 US$) in 1962 in Dominican Republic?
Provide a succinct answer. -2.40e+07. What is the difference between the Taxes (in constant 2015 US$) of 1961 and Taxes (in constant 2015 US$) of 1963 in Dominican Republic?
Give a very brief answer. -3.36e+07. What is the difference between the Taxes (in constant 2015 US$) in 1962 and Taxes (in constant 2015 US$) in 1963 in Dominican Republic?
Keep it short and to the point. -9.60e+06. What is the ratio of the Taxes (in constant 2015 US$) in 1960 in Burkina Faso to that in Burundi?
Make the answer very short. 1.57. What is the ratio of the Taxes (in constant 2015 US$) of 1961 in Burkina Faso to that in Burundi?
Provide a short and direct response. 1.66. What is the ratio of the Taxes (in constant 2015 US$) in 1962 in Burkina Faso to that in Burundi?
Your answer should be compact. 2.24. What is the ratio of the Taxes (in constant 2015 US$) of 1963 in Burkina Faso to that in Burundi?
Give a very brief answer. 2.25. What is the ratio of the Taxes (in constant 2015 US$) in 1960 in Burkina Faso to that in Central African Republic?
Offer a very short reply. 2.7. What is the ratio of the Taxes (in constant 2015 US$) of 1961 in Burkina Faso to that in Central African Republic?
Provide a short and direct response. 2.59. What is the ratio of the Taxes (in constant 2015 US$) in 1962 in Burkina Faso to that in Central African Republic?
Your answer should be very brief. 2.74. What is the ratio of the Taxes (in constant 2015 US$) in 1963 in Burkina Faso to that in Central African Republic?
Ensure brevity in your answer.  2.41. What is the ratio of the Taxes (in constant 2015 US$) of 1960 in Burkina Faso to that in Chad?
Offer a terse response. 1.01. What is the ratio of the Taxes (in constant 2015 US$) in 1961 in Burkina Faso to that in Chad?
Your response must be concise. 1.02. What is the ratio of the Taxes (in constant 2015 US$) of 1962 in Burkina Faso to that in Chad?
Offer a terse response. 1.15. What is the ratio of the Taxes (in constant 2015 US$) of 1963 in Burkina Faso to that in Chad?
Offer a very short reply. 0.95. What is the ratio of the Taxes (in constant 2015 US$) of 1960 in Burkina Faso to that in Chile?
Provide a succinct answer. 0.06. What is the ratio of the Taxes (in constant 2015 US$) in 1961 in Burkina Faso to that in Chile?
Give a very brief answer. 0.05. What is the ratio of the Taxes (in constant 2015 US$) of 1962 in Burkina Faso to that in Chile?
Your answer should be very brief. 0.07. What is the ratio of the Taxes (in constant 2015 US$) of 1963 in Burkina Faso to that in Chile?
Provide a short and direct response. 0.07. What is the ratio of the Taxes (in constant 2015 US$) of 1960 in Burkina Faso to that in Dominican Republic?
Give a very brief answer. 0.11. What is the ratio of the Taxes (in constant 2015 US$) of 1961 in Burkina Faso to that in Dominican Republic?
Make the answer very short. 0.14. What is the ratio of the Taxes (in constant 2015 US$) of 1962 in Burkina Faso to that in Dominican Republic?
Your response must be concise. 0.14. What is the ratio of the Taxes (in constant 2015 US$) of 1963 in Burkina Faso to that in Dominican Republic?
Make the answer very short. 0.13. What is the ratio of the Taxes (in constant 2015 US$) in 1960 in Burundi to that in Central African Republic?
Provide a short and direct response. 1.72. What is the ratio of the Taxes (in constant 2015 US$) in 1961 in Burundi to that in Central African Republic?
Provide a succinct answer. 1.56. What is the ratio of the Taxes (in constant 2015 US$) of 1962 in Burundi to that in Central African Republic?
Give a very brief answer. 1.23. What is the ratio of the Taxes (in constant 2015 US$) in 1963 in Burundi to that in Central African Republic?
Your answer should be very brief. 1.07. What is the ratio of the Taxes (in constant 2015 US$) in 1960 in Burundi to that in Chad?
Ensure brevity in your answer.  0.64. What is the ratio of the Taxes (in constant 2015 US$) of 1961 in Burundi to that in Chad?
Offer a very short reply. 0.62. What is the ratio of the Taxes (in constant 2015 US$) of 1962 in Burundi to that in Chad?
Offer a terse response. 0.52. What is the ratio of the Taxes (in constant 2015 US$) of 1963 in Burundi to that in Chad?
Make the answer very short. 0.42. What is the ratio of the Taxes (in constant 2015 US$) of 1960 in Burundi to that in Chile?
Provide a succinct answer. 0.04. What is the ratio of the Taxes (in constant 2015 US$) in 1961 in Burundi to that in Chile?
Provide a short and direct response. 0.03. What is the ratio of the Taxes (in constant 2015 US$) in 1962 in Burundi to that in Chile?
Your response must be concise. 0.03. What is the ratio of the Taxes (in constant 2015 US$) in 1963 in Burundi to that in Chile?
Your response must be concise. 0.03. What is the ratio of the Taxes (in constant 2015 US$) of 1960 in Burundi to that in Dominican Republic?
Give a very brief answer. 0.07. What is the ratio of the Taxes (in constant 2015 US$) of 1961 in Burundi to that in Dominican Republic?
Your answer should be very brief. 0.08. What is the ratio of the Taxes (in constant 2015 US$) of 1962 in Burundi to that in Dominican Republic?
Provide a succinct answer. 0.06. What is the ratio of the Taxes (in constant 2015 US$) of 1963 in Burundi to that in Dominican Republic?
Your response must be concise. 0.06. What is the ratio of the Taxes (in constant 2015 US$) in 1960 in Central African Republic to that in Chad?
Provide a short and direct response. 0.37. What is the ratio of the Taxes (in constant 2015 US$) in 1961 in Central African Republic to that in Chad?
Give a very brief answer. 0.39. What is the ratio of the Taxes (in constant 2015 US$) in 1962 in Central African Republic to that in Chad?
Your response must be concise. 0.42. What is the ratio of the Taxes (in constant 2015 US$) of 1963 in Central African Republic to that in Chad?
Keep it short and to the point. 0.39. What is the ratio of the Taxes (in constant 2015 US$) of 1960 in Central African Republic to that in Chile?
Provide a short and direct response. 0.02. What is the ratio of the Taxes (in constant 2015 US$) of 1961 in Central African Republic to that in Chile?
Make the answer very short. 0.02. What is the ratio of the Taxes (in constant 2015 US$) in 1962 in Central African Republic to that in Chile?
Provide a succinct answer. 0.02. What is the ratio of the Taxes (in constant 2015 US$) of 1963 in Central African Republic to that in Chile?
Give a very brief answer. 0.03. What is the ratio of the Taxes (in constant 2015 US$) of 1960 in Central African Republic to that in Dominican Republic?
Make the answer very short. 0.04. What is the ratio of the Taxes (in constant 2015 US$) of 1961 in Central African Republic to that in Dominican Republic?
Your answer should be compact. 0.05. What is the ratio of the Taxes (in constant 2015 US$) of 1962 in Central African Republic to that in Dominican Republic?
Ensure brevity in your answer.  0.05. What is the ratio of the Taxes (in constant 2015 US$) of 1963 in Central African Republic to that in Dominican Republic?
Provide a succinct answer. 0.05. What is the ratio of the Taxes (in constant 2015 US$) in 1960 in Chad to that in Chile?
Keep it short and to the point. 0.06. What is the ratio of the Taxes (in constant 2015 US$) of 1961 in Chad to that in Chile?
Provide a short and direct response. 0.05. What is the ratio of the Taxes (in constant 2015 US$) of 1962 in Chad to that in Chile?
Provide a short and direct response. 0.06. What is the ratio of the Taxes (in constant 2015 US$) in 1963 in Chad to that in Chile?
Your response must be concise. 0.08. What is the ratio of the Taxes (in constant 2015 US$) in 1960 in Chad to that in Dominican Republic?
Ensure brevity in your answer.  0.11. What is the ratio of the Taxes (in constant 2015 US$) in 1961 in Chad to that in Dominican Republic?
Keep it short and to the point. 0.13. What is the ratio of the Taxes (in constant 2015 US$) of 1962 in Chad to that in Dominican Republic?
Ensure brevity in your answer.  0.12. What is the ratio of the Taxes (in constant 2015 US$) of 1963 in Chad to that in Dominican Republic?
Your answer should be compact. 0.14. What is the ratio of the Taxes (in constant 2015 US$) of 1960 in Chile to that in Dominican Republic?
Your answer should be very brief. 1.99. What is the ratio of the Taxes (in constant 2015 US$) of 1961 in Chile to that in Dominican Republic?
Provide a succinct answer. 2.79. What is the ratio of the Taxes (in constant 2015 US$) in 1962 in Chile to that in Dominican Republic?
Your answer should be very brief. 2.16. What is the ratio of the Taxes (in constant 2015 US$) in 1963 in Chile to that in Dominican Republic?
Your answer should be compact. 1.82. What is the difference between the highest and the second highest Taxes (in constant 2015 US$) in 1960?
Ensure brevity in your answer.  9.50e+07. What is the difference between the highest and the second highest Taxes (in constant 2015 US$) in 1961?
Your response must be concise. 1.53e+08. What is the difference between the highest and the second highest Taxes (in constant 2015 US$) in 1962?
Your answer should be very brief. 1.28e+08. What is the difference between the highest and the second highest Taxes (in constant 2015 US$) of 1963?
Your answer should be very brief. 9.74e+07. What is the difference between the highest and the lowest Taxes (in constant 2015 US$) in 1960?
Provide a short and direct response. 1.87e+08. What is the difference between the highest and the lowest Taxes (in constant 2015 US$) in 1961?
Keep it short and to the point. 2.35e+08. What is the difference between the highest and the lowest Taxes (in constant 2015 US$) of 1962?
Your answer should be compact. 2.31e+08. What is the difference between the highest and the lowest Taxes (in constant 2015 US$) of 1963?
Offer a terse response. 2.10e+08. 